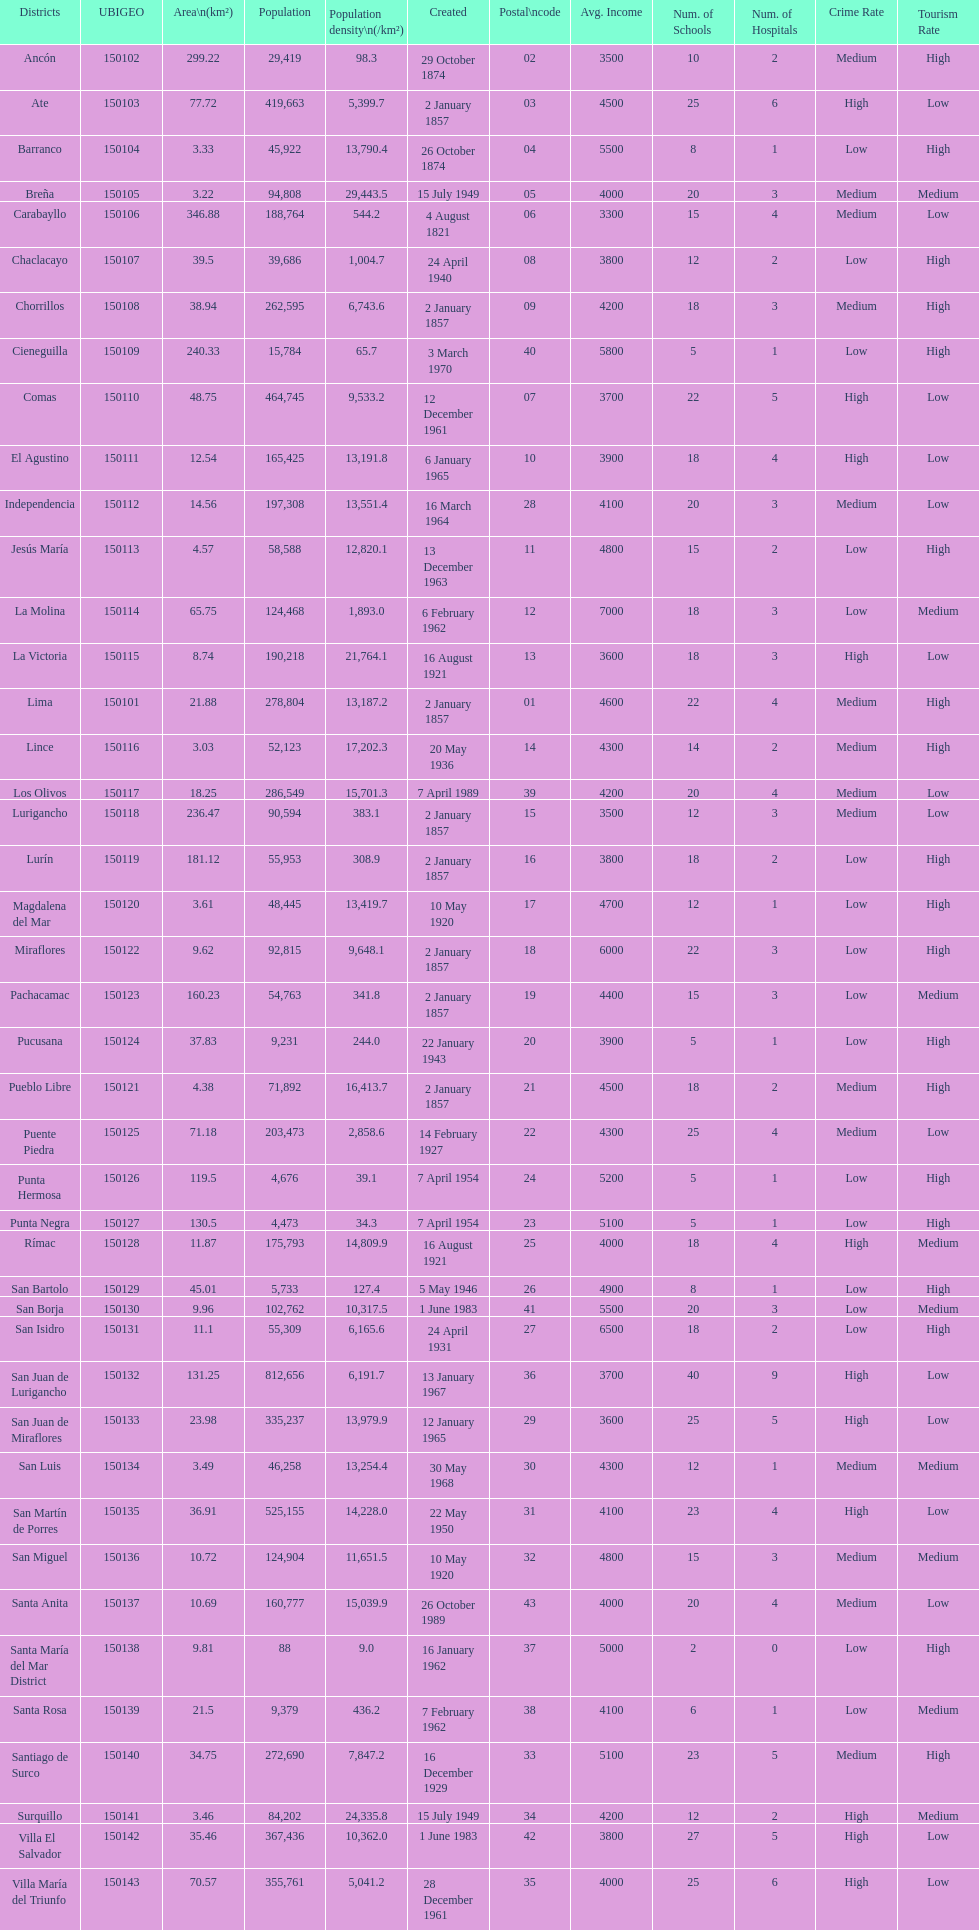How many districts have a population density of at lest 1000.0? 31. 